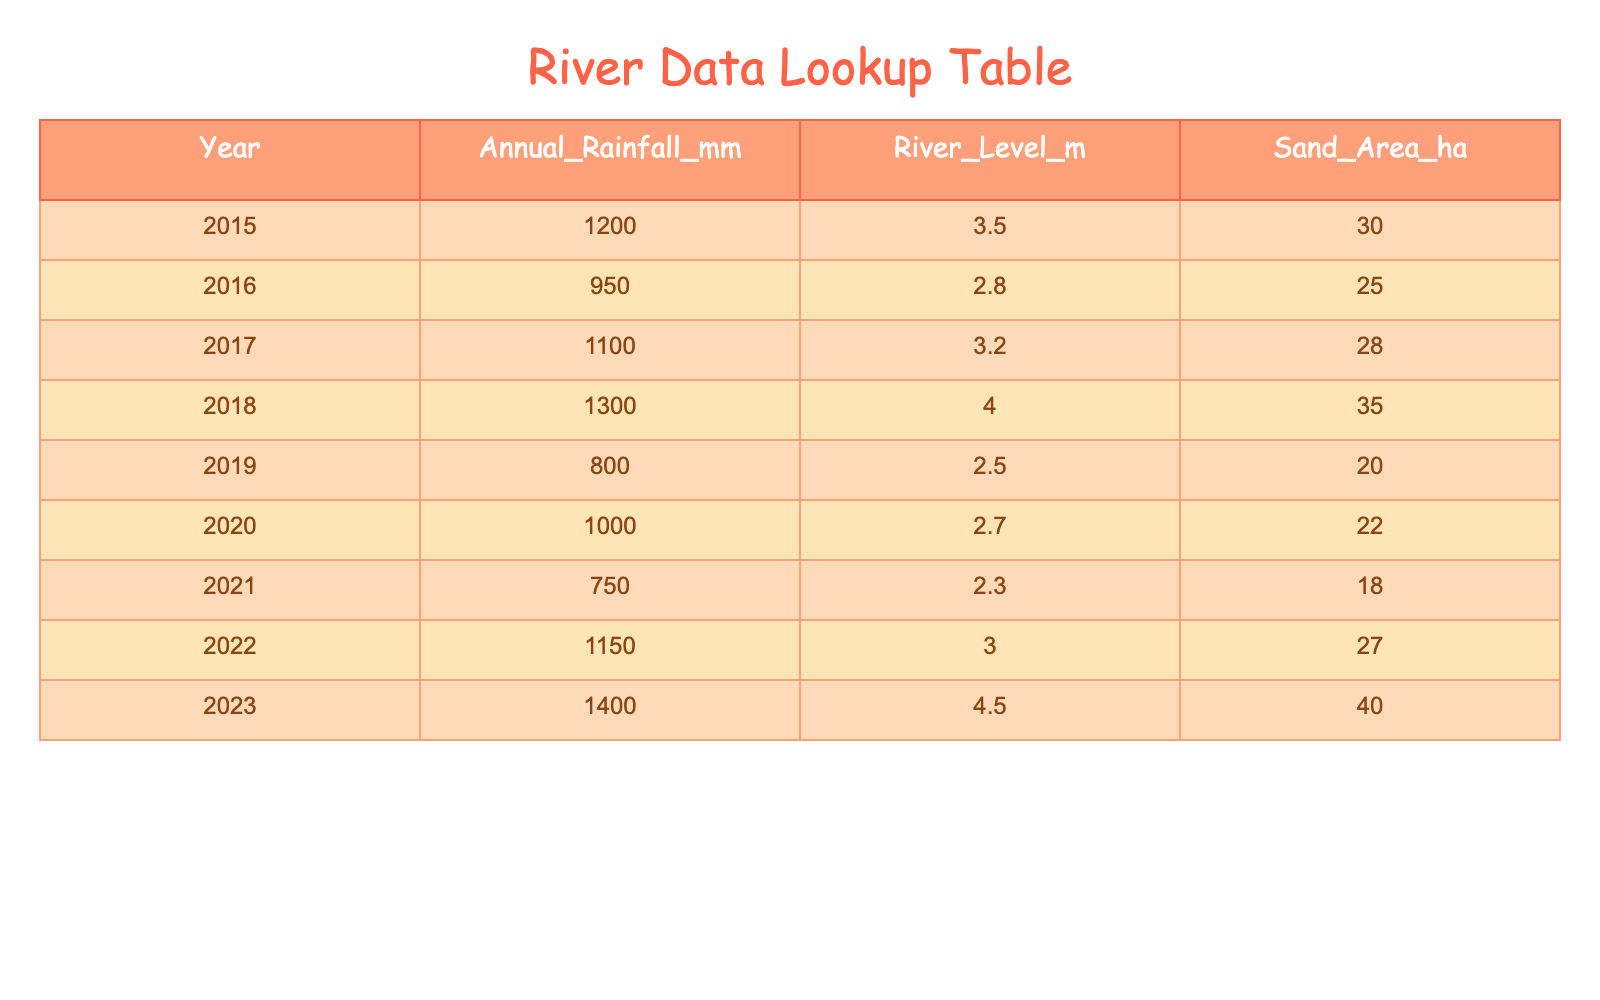What was the annual rainfall in 2023? The table shows that in the year 2023, the annual rainfall was recorded at 1400 mm.
Answer: 1400 mm Which year had the lowest river level? Looking at the River Level column, 2.3 m in 2021 is the lowest value compared to other years.
Answer: 2021 What is the total sand area for the years 2015 to 2019? Adding the sand area for the years 2015 (30 ha), 2016 (25 ha), 2017 (28 ha), 2018 (35 ha), and 2019 (20 ha) gives us a total of 30 + 25 + 28 + 35 + 20 = 138 ha.
Answer: 138 ha Was the annual rainfall higher in 2022 than in 2020? Comparing the values, 2022 had 1150 mm of rainfall, which is higher than 2020's 1000 mm.
Answer: Yes What is the average river level from 2015 to 2023? To find the average river level, sum the river levels for each year (3.5 + 2.8 + 3.2 + 4.0 + 2.5 + 2.7 + 2.3 + 3.0 + 4.5) which totals 25.5 m, then divide by the number of years (9). Thus, 25.5/9 = 2.83 m.
Answer: 2.83 m How many hectares of sand area were there in 2018 compared to 2019? In 2018, the sand area was 35 ha, while in 2019, it was 20 ha. Thus, 35 ha is more than 20 ha.
Answer: 35 ha is more than 20 ha What was the change in river level from 2015 to 2023? The river level in 2015 was 3.5 m and in 2023 it rose to 4.5 m. The change is 4.5 m - 3.5 m = 1 m increase.
Answer: 1 m increase In which year did the river level exceed 4 meters? The table indicates that the river level exceeded 4 meters only in the year 2023 when it reached 4.5 m.
Answer: 2023 How many years had an annual rainfall of less than 1000 mm? Looking at the Annual Rainfall column, the years 2016 (950 mm), 2019 (800 mm), and 2021 (750 mm) had less than 1000 mm. That totals 3 years.
Answer: 3 years 